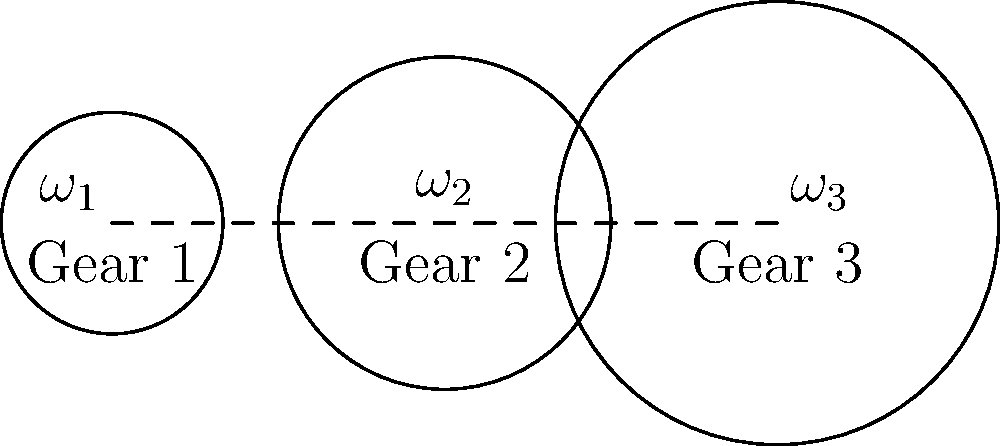In a simple gear train consisting of three gears as shown in the diagram, Gear 1 has 20 teeth and rotates at 100 rpm clockwise. Gear 2 has 30 teeth, and Gear 3 has 40 teeth. Calculate the speed and direction of rotation of Gear 3. To solve this problem, let's follow these steps:

1. Understand the gear ratio concept:
   The gear ratio between two meshing gears is inversely proportional to their number of teeth and directly proportional to their angular velocities.

2. Calculate the gear ratio between Gear 1 and Gear 2:
   $\frac{\omega_1}{\omega_2} = \frac{N_2}{N_1}$, where $\omega$ is angular velocity and $N$ is number of teeth.
   $\frac{100}{|\omega_2|} = \frac{30}{20}$
   $|\omega_2| = \frac{100 \times 20}{30} = 66.67$ rpm

3. Determine the direction of Gear 2:
   Since Gear 1 rotates clockwise, Gear 2 will rotate counterclockwise.

4. Calculate the gear ratio between Gear 2 and Gear 3:
   $\frac{\omega_2}{\omega_3} = \frac{N_3}{N_2}$
   $\frac{66.67}{|\omega_3|} = \frac{40}{30}$
   $|\omega_3| = \frac{66.67 \times 30}{40} = 50$ rpm

5. Determine the direction of Gear 3:
   Since Gear 2 rotates counterclockwise, Gear 3 will rotate clockwise.

Therefore, Gear 3 rotates at 50 rpm in the clockwise direction.
Answer: 50 rpm clockwise 